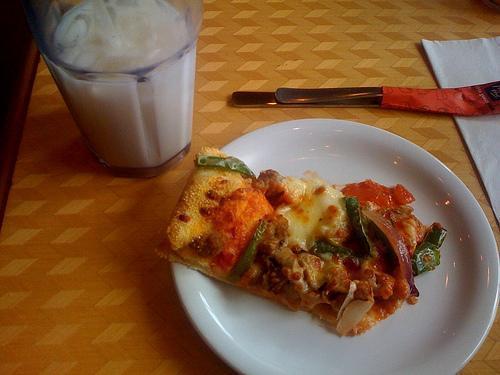How many slices of pizza is there?
Give a very brief answer. 1. How many slices are on the plate?
Give a very brief answer. 1. How many pieces are there?
Give a very brief answer. 1. How many tomato slices are on the salad?
Give a very brief answer. 0. How many different foods are on the plate?
Give a very brief answer. 1. How many giraffes are there?
Give a very brief answer. 0. 